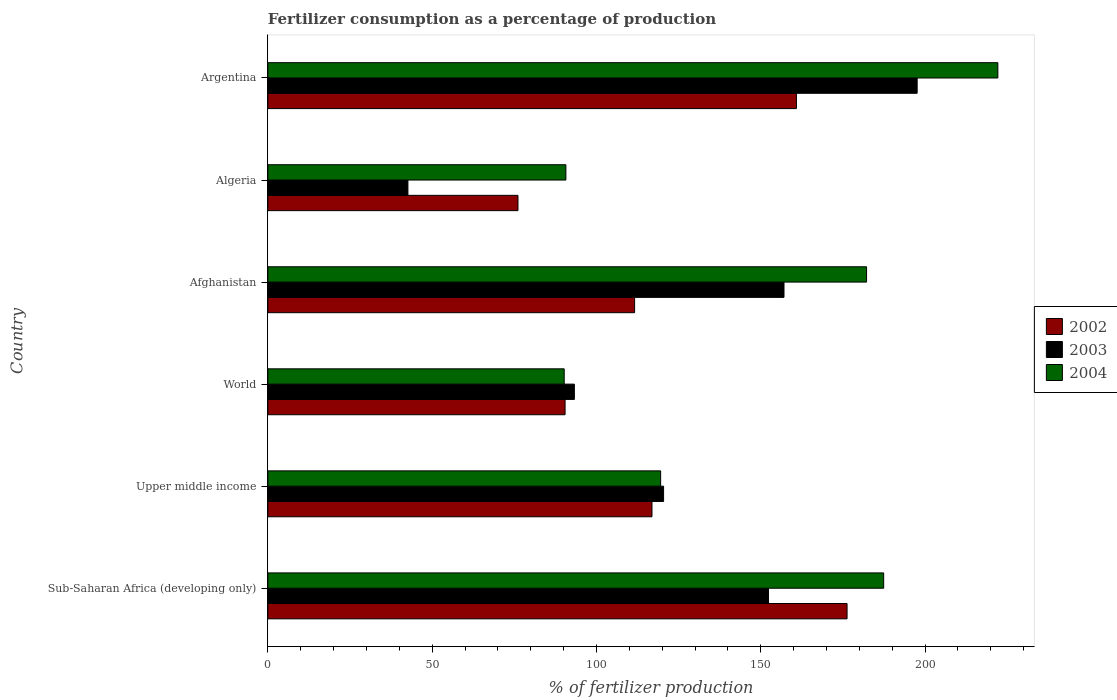How many different coloured bars are there?
Ensure brevity in your answer.  3. How many groups of bars are there?
Provide a succinct answer. 6. What is the label of the 6th group of bars from the top?
Give a very brief answer. Sub-Saharan Africa (developing only). In how many cases, is the number of bars for a given country not equal to the number of legend labels?
Your answer should be very brief. 0. What is the percentage of fertilizers consumed in 2004 in Argentina?
Ensure brevity in your answer.  222.14. Across all countries, what is the maximum percentage of fertilizers consumed in 2003?
Offer a terse response. 197.58. Across all countries, what is the minimum percentage of fertilizers consumed in 2004?
Keep it short and to the point. 90.18. In which country was the percentage of fertilizers consumed in 2003 maximum?
Offer a very short reply. Argentina. In which country was the percentage of fertilizers consumed in 2002 minimum?
Give a very brief answer. Algeria. What is the total percentage of fertilizers consumed in 2003 in the graph?
Give a very brief answer. 763.33. What is the difference between the percentage of fertilizers consumed in 2002 in Argentina and that in World?
Provide a short and direct response. 70.4. What is the difference between the percentage of fertilizers consumed in 2002 in Algeria and the percentage of fertilizers consumed in 2003 in Upper middle income?
Make the answer very short. -44.31. What is the average percentage of fertilizers consumed in 2002 per country?
Give a very brief answer. 122.03. What is the difference between the percentage of fertilizers consumed in 2003 and percentage of fertilizers consumed in 2002 in Upper middle income?
Provide a succinct answer. 3.53. What is the ratio of the percentage of fertilizers consumed in 2002 in Upper middle income to that in World?
Ensure brevity in your answer.  1.29. Is the difference between the percentage of fertilizers consumed in 2003 in Upper middle income and World greater than the difference between the percentage of fertilizers consumed in 2002 in Upper middle income and World?
Provide a short and direct response. Yes. What is the difference between the highest and the second highest percentage of fertilizers consumed in 2003?
Keep it short and to the point. 40.52. What is the difference between the highest and the lowest percentage of fertilizers consumed in 2004?
Your response must be concise. 131.96. Is the sum of the percentage of fertilizers consumed in 2002 in Afghanistan and World greater than the maximum percentage of fertilizers consumed in 2003 across all countries?
Keep it short and to the point. Yes. What does the 1st bar from the bottom in World represents?
Offer a very short reply. 2002. How many bars are there?
Offer a very short reply. 18. Are all the bars in the graph horizontal?
Give a very brief answer. Yes. Are the values on the major ticks of X-axis written in scientific E-notation?
Your response must be concise. No. Does the graph contain any zero values?
Your answer should be very brief. No. Does the graph contain grids?
Provide a short and direct response. No. How are the legend labels stacked?
Provide a succinct answer. Vertical. What is the title of the graph?
Your response must be concise. Fertilizer consumption as a percentage of production. What is the label or title of the X-axis?
Your response must be concise. % of fertilizer production. What is the label or title of the Y-axis?
Provide a short and direct response. Country. What is the % of fertilizer production in 2002 in Sub-Saharan Africa (developing only)?
Offer a terse response. 176.25. What is the % of fertilizer production of 2003 in Sub-Saharan Africa (developing only)?
Your answer should be compact. 152.35. What is the % of fertilizer production in 2004 in Sub-Saharan Africa (developing only)?
Make the answer very short. 187.4. What is the % of fertilizer production in 2002 in Upper middle income?
Provide a succinct answer. 116.9. What is the % of fertilizer production in 2003 in Upper middle income?
Offer a very short reply. 120.42. What is the % of fertilizer production in 2004 in Upper middle income?
Offer a terse response. 119.53. What is the % of fertilizer production in 2002 in World?
Offer a very short reply. 90.45. What is the % of fertilizer production in 2003 in World?
Provide a short and direct response. 93.27. What is the % of fertilizer production of 2004 in World?
Keep it short and to the point. 90.18. What is the % of fertilizer production of 2002 in Afghanistan?
Your response must be concise. 111.6. What is the % of fertilizer production in 2003 in Afghanistan?
Your response must be concise. 157.07. What is the % of fertilizer production of 2004 in Afghanistan?
Offer a terse response. 182.19. What is the % of fertilizer production of 2002 in Algeria?
Offer a very short reply. 76.11. What is the % of fertilizer production of 2003 in Algeria?
Your answer should be very brief. 42.63. What is the % of fertilizer production in 2004 in Algeria?
Make the answer very short. 90.69. What is the % of fertilizer production in 2002 in Argentina?
Offer a very short reply. 160.85. What is the % of fertilizer production of 2003 in Argentina?
Ensure brevity in your answer.  197.58. What is the % of fertilizer production of 2004 in Argentina?
Provide a short and direct response. 222.14. Across all countries, what is the maximum % of fertilizer production in 2002?
Your answer should be compact. 176.25. Across all countries, what is the maximum % of fertilizer production of 2003?
Keep it short and to the point. 197.58. Across all countries, what is the maximum % of fertilizer production of 2004?
Provide a succinct answer. 222.14. Across all countries, what is the minimum % of fertilizer production of 2002?
Keep it short and to the point. 76.11. Across all countries, what is the minimum % of fertilizer production of 2003?
Your answer should be very brief. 42.63. Across all countries, what is the minimum % of fertilizer production in 2004?
Offer a terse response. 90.18. What is the total % of fertilizer production in 2002 in the graph?
Your answer should be very brief. 732.17. What is the total % of fertilizer production of 2003 in the graph?
Offer a terse response. 763.33. What is the total % of fertilizer production in 2004 in the graph?
Provide a short and direct response. 892.13. What is the difference between the % of fertilizer production of 2002 in Sub-Saharan Africa (developing only) and that in Upper middle income?
Your answer should be very brief. 59.36. What is the difference between the % of fertilizer production of 2003 in Sub-Saharan Africa (developing only) and that in Upper middle income?
Your response must be concise. 31.93. What is the difference between the % of fertilizer production in 2004 in Sub-Saharan Africa (developing only) and that in Upper middle income?
Offer a very short reply. 67.87. What is the difference between the % of fertilizer production of 2002 in Sub-Saharan Africa (developing only) and that in World?
Your answer should be compact. 85.8. What is the difference between the % of fertilizer production of 2003 in Sub-Saharan Africa (developing only) and that in World?
Ensure brevity in your answer.  59.08. What is the difference between the % of fertilizer production of 2004 in Sub-Saharan Africa (developing only) and that in World?
Your answer should be compact. 97.21. What is the difference between the % of fertilizer production in 2002 in Sub-Saharan Africa (developing only) and that in Afghanistan?
Your response must be concise. 64.65. What is the difference between the % of fertilizer production of 2003 in Sub-Saharan Africa (developing only) and that in Afghanistan?
Make the answer very short. -4.71. What is the difference between the % of fertilizer production of 2004 in Sub-Saharan Africa (developing only) and that in Afghanistan?
Your response must be concise. 5.21. What is the difference between the % of fertilizer production in 2002 in Sub-Saharan Africa (developing only) and that in Algeria?
Your answer should be very brief. 100.14. What is the difference between the % of fertilizer production of 2003 in Sub-Saharan Africa (developing only) and that in Algeria?
Keep it short and to the point. 109.73. What is the difference between the % of fertilizer production in 2004 in Sub-Saharan Africa (developing only) and that in Algeria?
Your answer should be compact. 96.7. What is the difference between the % of fertilizer production in 2002 in Sub-Saharan Africa (developing only) and that in Argentina?
Your answer should be compact. 15.4. What is the difference between the % of fertilizer production in 2003 in Sub-Saharan Africa (developing only) and that in Argentina?
Provide a succinct answer. -45.23. What is the difference between the % of fertilizer production in 2004 in Sub-Saharan Africa (developing only) and that in Argentina?
Your response must be concise. -34.75. What is the difference between the % of fertilizer production in 2002 in Upper middle income and that in World?
Your response must be concise. 26.45. What is the difference between the % of fertilizer production of 2003 in Upper middle income and that in World?
Your answer should be compact. 27.15. What is the difference between the % of fertilizer production of 2004 in Upper middle income and that in World?
Offer a terse response. 29.35. What is the difference between the % of fertilizer production in 2002 in Upper middle income and that in Afghanistan?
Offer a very short reply. 5.29. What is the difference between the % of fertilizer production of 2003 in Upper middle income and that in Afghanistan?
Give a very brief answer. -36.64. What is the difference between the % of fertilizer production of 2004 in Upper middle income and that in Afghanistan?
Ensure brevity in your answer.  -62.66. What is the difference between the % of fertilizer production in 2002 in Upper middle income and that in Algeria?
Ensure brevity in your answer.  40.78. What is the difference between the % of fertilizer production in 2003 in Upper middle income and that in Algeria?
Your answer should be very brief. 77.8. What is the difference between the % of fertilizer production of 2004 in Upper middle income and that in Algeria?
Your answer should be compact. 28.84. What is the difference between the % of fertilizer production in 2002 in Upper middle income and that in Argentina?
Provide a succinct answer. -43.96. What is the difference between the % of fertilizer production in 2003 in Upper middle income and that in Argentina?
Give a very brief answer. -77.16. What is the difference between the % of fertilizer production in 2004 in Upper middle income and that in Argentina?
Your response must be concise. -102.62. What is the difference between the % of fertilizer production of 2002 in World and that in Afghanistan?
Ensure brevity in your answer.  -21.15. What is the difference between the % of fertilizer production in 2003 in World and that in Afghanistan?
Offer a terse response. -63.79. What is the difference between the % of fertilizer production of 2004 in World and that in Afghanistan?
Your answer should be compact. -92.01. What is the difference between the % of fertilizer production of 2002 in World and that in Algeria?
Ensure brevity in your answer.  14.34. What is the difference between the % of fertilizer production in 2003 in World and that in Algeria?
Provide a short and direct response. 50.65. What is the difference between the % of fertilizer production of 2004 in World and that in Algeria?
Offer a terse response. -0.51. What is the difference between the % of fertilizer production in 2002 in World and that in Argentina?
Your answer should be compact. -70.4. What is the difference between the % of fertilizer production in 2003 in World and that in Argentina?
Your answer should be compact. -104.31. What is the difference between the % of fertilizer production of 2004 in World and that in Argentina?
Offer a very short reply. -131.96. What is the difference between the % of fertilizer production of 2002 in Afghanistan and that in Algeria?
Make the answer very short. 35.49. What is the difference between the % of fertilizer production in 2003 in Afghanistan and that in Algeria?
Provide a succinct answer. 114.44. What is the difference between the % of fertilizer production of 2004 in Afghanistan and that in Algeria?
Offer a very short reply. 91.5. What is the difference between the % of fertilizer production in 2002 in Afghanistan and that in Argentina?
Keep it short and to the point. -49.25. What is the difference between the % of fertilizer production in 2003 in Afghanistan and that in Argentina?
Offer a very short reply. -40.52. What is the difference between the % of fertilizer production in 2004 in Afghanistan and that in Argentina?
Keep it short and to the point. -39.96. What is the difference between the % of fertilizer production of 2002 in Algeria and that in Argentina?
Provide a short and direct response. -84.74. What is the difference between the % of fertilizer production in 2003 in Algeria and that in Argentina?
Offer a terse response. -154.96. What is the difference between the % of fertilizer production in 2004 in Algeria and that in Argentina?
Your answer should be very brief. -131.45. What is the difference between the % of fertilizer production in 2002 in Sub-Saharan Africa (developing only) and the % of fertilizer production in 2003 in Upper middle income?
Give a very brief answer. 55.83. What is the difference between the % of fertilizer production of 2002 in Sub-Saharan Africa (developing only) and the % of fertilizer production of 2004 in Upper middle income?
Your answer should be compact. 56.73. What is the difference between the % of fertilizer production in 2003 in Sub-Saharan Africa (developing only) and the % of fertilizer production in 2004 in Upper middle income?
Give a very brief answer. 32.82. What is the difference between the % of fertilizer production in 2002 in Sub-Saharan Africa (developing only) and the % of fertilizer production in 2003 in World?
Provide a short and direct response. 82.98. What is the difference between the % of fertilizer production in 2002 in Sub-Saharan Africa (developing only) and the % of fertilizer production in 2004 in World?
Your answer should be very brief. 86.07. What is the difference between the % of fertilizer production of 2003 in Sub-Saharan Africa (developing only) and the % of fertilizer production of 2004 in World?
Make the answer very short. 62.17. What is the difference between the % of fertilizer production of 2002 in Sub-Saharan Africa (developing only) and the % of fertilizer production of 2003 in Afghanistan?
Offer a very short reply. 19.19. What is the difference between the % of fertilizer production in 2002 in Sub-Saharan Africa (developing only) and the % of fertilizer production in 2004 in Afghanistan?
Offer a terse response. -5.93. What is the difference between the % of fertilizer production of 2003 in Sub-Saharan Africa (developing only) and the % of fertilizer production of 2004 in Afghanistan?
Give a very brief answer. -29.84. What is the difference between the % of fertilizer production in 2002 in Sub-Saharan Africa (developing only) and the % of fertilizer production in 2003 in Algeria?
Your answer should be very brief. 133.63. What is the difference between the % of fertilizer production in 2002 in Sub-Saharan Africa (developing only) and the % of fertilizer production in 2004 in Algeria?
Your answer should be compact. 85.56. What is the difference between the % of fertilizer production in 2003 in Sub-Saharan Africa (developing only) and the % of fertilizer production in 2004 in Algeria?
Give a very brief answer. 61.66. What is the difference between the % of fertilizer production in 2002 in Sub-Saharan Africa (developing only) and the % of fertilizer production in 2003 in Argentina?
Provide a succinct answer. -21.33. What is the difference between the % of fertilizer production of 2002 in Sub-Saharan Africa (developing only) and the % of fertilizer production of 2004 in Argentina?
Provide a succinct answer. -45.89. What is the difference between the % of fertilizer production in 2003 in Sub-Saharan Africa (developing only) and the % of fertilizer production in 2004 in Argentina?
Offer a terse response. -69.79. What is the difference between the % of fertilizer production in 2002 in Upper middle income and the % of fertilizer production in 2003 in World?
Your response must be concise. 23.62. What is the difference between the % of fertilizer production in 2002 in Upper middle income and the % of fertilizer production in 2004 in World?
Offer a terse response. 26.71. What is the difference between the % of fertilizer production in 2003 in Upper middle income and the % of fertilizer production in 2004 in World?
Your response must be concise. 30.24. What is the difference between the % of fertilizer production of 2002 in Upper middle income and the % of fertilizer production of 2003 in Afghanistan?
Your answer should be compact. -40.17. What is the difference between the % of fertilizer production of 2002 in Upper middle income and the % of fertilizer production of 2004 in Afghanistan?
Provide a short and direct response. -65.29. What is the difference between the % of fertilizer production of 2003 in Upper middle income and the % of fertilizer production of 2004 in Afghanistan?
Your response must be concise. -61.76. What is the difference between the % of fertilizer production of 2002 in Upper middle income and the % of fertilizer production of 2003 in Algeria?
Offer a terse response. 74.27. What is the difference between the % of fertilizer production of 2002 in Upper middle income and the % of fertilizer production of 2004 in Algeria?
Keep it short and to the point. 26.2. What is the difference between the % of fertilizer production in 2003 in Upper middle income and the % of fertilizer production in 2004 in Algeria?
Offer a terse response. 29.73. What is the difference between the % of fertilizer production in 2002 in Upper middle income and the % of fertilizer production in 2003 in Argentina?
Provide a succinct answer. -80.69. What is the difference between the % of fertilizer production in 2002 in Upper middle income and the % of fertilizer production in 2004 in Argentina?
Your answer should be very brief. -105.25. What is the difference between the % of fertilizer production in 2003 in Upper middle income and the % of fertilizer production in 2004 in Argentina?
Provide a short and direct response. -101.72. What is the difference between the % of fertilizer production of 2002 in World and the % of fertilizer production of 2003 in Afghanistan?
Your response must be concise. -66.62. What is the difference between the % of fertilizer production of 2002 in World and the % of fertilizer production of 2004 in Afghanistan?
Keep it short and to the point. -91.74. What is the difference between the % of fertilizer production in 2003 in World and the % of fertilizer production in 2004 in Afghanistan?
Offer a very short reply. -88.91. What is the difference between the % of fertilizer production of 2002 in World and the % of fertilizer production of 2003 in Algeria?
Provide a short and direct response. 47.82. What is the difference between the % of fertilizer production in 2002 in World and the % of fertilizer production in 2004 in Algeria?
Your answer should be very brief. -0.24. What is the difference between the % of fertilizer production in 2003 in World and the % of fertilizer production in 2004 in Algeria?
Make the answer very short. 2.58. What is the difference between the % of fertilizer production in 2002 in World and the % of fertilizer production in 2003 in Argentina?
Your response must be concise. -107.14. What is the difference between the % of fertilizer production of 2002 in World and the % of fertilizer production of 2004 in Argentina?
Your answer should be compact. -131.7. What is the difference between the % of fertilizer production of 2003 in World and the % of fertilizer production of 2004 in Argentina?
Your answer should be very brief. -128.87. What is the difference between the % of fertilizer production in 2002 in Afghanistan and the % of fertilizer production in 2003 in Algeria?
Offer a terse response. 68.98. What is the difference between the % of fertilizer production of 2002 in Afghanistan and the % of fertilizer production of 2004 in Algeria?
Offer a terse response. 20.91. What is the difference between the % of fertilizer production in 2003 in Afghanistan and the % of fertilizer production in 2004 in Algeria?
Provide a succinct answer. 66.37. What is the difference between the % of fertilizer production of 2002 in Afghanistan and the % of fertilizer production of 2003 in Argentina?
Ensure brevity in your answer.  -85.98. What is the difference between the % of fertilizer production of 2002 in Afghanistan and the % of fertilizer production of 2004 in Argentina?
Your response must be concise. -110.54. What is the difference between the % of fertilizer production in 2003 in Afghanistan and the % of fertilizer production in 2004 in Argentina?
Make the answer very short. -65.08. What is the difference between the % of fertilizer production in 2002 in Algeria and the % of fertilizer production in 2003 in Argentina?
Your answer should be compact. -121.47. What is the difference between the % of fertilizer production of 2002 in Algeria and the % of fertilizer production of 2004 in Argentina?
Provide a succinct answer. -146.03. What is the difference between the % of fertilizer production of 2003 in Algeria and the % of fertilizer production of 2004 in Argentina?
Your response must be concise. -179.52. What is the average % of fertilizer production of 2002 per country?
Ensure brevity in your answer.  122.03. What is the average % of fertilizer production of 2003 per country?
Provide a short and direct response. 127.22. What is the average % of fertilizer production in 2004 per country?
Ensure brevity in your answer.  148.69. What is the difference between the % of fertilizer production of 2002 and % of fertilizer production of 2003 in Sub-Saharan Africa (developing only)?
Make the answer very short. 23.9. What is the difference between the % of fertilizer production in 2002 and % of fertilizer production in 2004 in Sub-Saharan Africa (developing only)?
Give a very brief answer. -11.14. What is the difference between the % of fertilizer production in 2003 and % of fertilizer production in 2004 in Sub-Saharan Africa (developing only)?
Your response must be concise. -35.04. What is the difference between the % of fertilizer production in 2002 and % of fertilizer production in 2003 in Upper middle income?
Your answer should be compact. -3.53. What is the difference between the % of fertilizer production in 2002 and % of fertilizer production in 2004 in Upper middle income?
Keep it short and to the point. -2.63. What is the difference between the % of fertilizer production of 2003 and % of fertilizer production of 2004 in Upper middle income?
Provide a short and direct response. 0.89. What is the difference between the % of fertilizer production in 2002 and % of fertilizer production in 2003 in World?
Ensure brevity in your answer.  -2.83. What is the difference between the % of fertilizer production in 2002 and % of fertilizer production in 2004 in World?
Keep it short and to the point. 0.27. What is the difference between the % of fertilizer production in 2003 and % of fertilizer production in 2004 in World?
Your answer should be compact. 3.09. What is the difference between the % of fertilizer production of 2002 and % of fertilizer production of 2003 in Afghanistan?
Keep it short and to the point. -45.46. What is the difference between the % of fertilizer production in 2002 and % of fertilizer production in 2004 in Afghanistan?
Provide a short and direct response. -70.58. What is the difference between the % of fertilizer production of 2003 and % of fertilizer production of 2004 in Afghanistan?
Give a very brief answer. -25.12. What is the difference between the % of fertilizer production of 2002 and % of fertilizer production of 2003 in Algeria?
Your response must be concise. 33.49. What is the difference between the % of fertilizer production of 2002 and % of fertilizer production of 2004 in Algeria?
Provide a succinct answer. -14.58. What is the difference between the % of fertilizer production in 2003 and % of fertilizer production in 2004 in Algeria?
Your answer should be very brief. -48.06. What is the difference between the % of fertilizer production in 2002 and % of fertilizer production in 2003 in Argentina?
Your answer should be compact. -36.73. What is the difference between the % of fertilizer production in 2002 and % of fertilizer production in 2004 in Argentina?
Provide a succinct answer. -61.29. What is the difference between the % of fertilizer production in 2003 and % of fertilizer production in 2004 in Argentina?
Your answer should be compact. -24.56. What is the ratio of the % of fertilizer production of 2002 in Sub-Saharan Africa (developing only) to that in Upper middle income?
Ensure brevity in your answer.  1.51. What is the ratio of the % of fertilizer production in 2003 in Sub-Saharan Africa (developing only) to that in Upper middle income?
Provide a short and direct response. 1.27. What is the ratio of the % of fertilizer production of 2004 in Sub-Saharan Africa (developing only) to that in Upper middle income?
Provide a short and direct response. 1.57. What is the ratio of the % of fertilizer production in 2002 in Sub-Saharan Africa (developing only) to that in World?
Provide a succinct answer. 1.95. What is the ratio of the % of fertilizer production of 2003 in Sub-Saharan Africa (developing only) to that in World?
Ensure brevity in your answer.  1.63. What is the ratio of the % of fertilizer production of 2004 in Sub-Saharan Africa (developing only) to that in World?
Make the answer very short. 2.08. What is the ratio of the % of fertilizer production of 2002 in Sub-Saharan Africa (developing only) to that in Afghanistan?
Your answer should be very brief. 1.58. What is the ratio of the % of fertilizer production in 2004 in Sub-Saharan Africa (developing only) to that in Afghanistan?
Provide a succinct answer. 1.03. What is the ratio of the % of fertilizer production of 2002 in Sub-Saharan Africa (developing only) to that in Algeria?
Make the answer very short. 2.32. What is the ratio of the % of fertilizer production in 2003 in Sub-Saharan Africa (developing only) to that in Algeria?
Give a very brief answer. 3.57. What is the ratio of the % of fertilizer production in 2004 in Sub-Saharan Africa (developing only) to that in Algeria?
Ensure brevity in your answer.  2.07. What is the ratio of the % of fertilizer production in 2002 in Sub-Saharan Africa (developing only) to that in Argentina?
Your answer should be very brief. 1.1. What is the ratio of the % of fertilizer production of 2003 in Sub-Saharan Africa (developing only) to that in Argentina?
Give a very brief answer. 0.77. What is the ratio of the % of fertilizer production of 2004 in Sub-Saharan Africa (developing only) to that in Argentina?
Offer a very short reply. 0.84. What is the ratio of the % of fertilizer production in 2002 in Upper middle income to that in World?
Your answer should be compact. 1.29. What is the ratio of the % of fertilizer production of 2003 in Upper middle income to that in World?
Make the answer very short. 1.29. What is the ratio of the % of fertilizer production of 2004 in Upper middle income to that in World?
Give a very brief answer. 1.33. What is the ratio of the % of fertilizer production of 2002 in Upper middle income to that in Afghanistan?
Your response must be concise. 1.05. What is the ratio of the % of fertilizer production in 2003 in Upper middle income to that in Afghanistan?
Your answer should be very brief. 0.77. What is the ratio of the % of fertilizer production in 2004 in Upper middle income to that in Afghanistan?
Your answer should be compact. 0.66. What is the ratio of the % of fertilizer production in 2002 in Upper middle income to that in Algeria?
Your answer should be very brief. 1.54. What is the ratio of the % of fertilizer production of 2003 in Upper middle income to that in Algeria?
Provide a short and direct response. 2.83. What is the ratio of the % of fertilizer production in 2004 in Upper middle income to that in Algeria?
Provide a short and direct response. 1.32. What is the ratio of the % of fertilizer production in 2002 in Upper middle income to that in Argentina?
Provide a succinct answer. 0.73. What is the ratio of the % of fertilizer production in 2003 in Upper middle income to that in Argentina?
Your answer should be very brief. 0.61. What is the ratio of the % of fertilizer production of 2004 in Upper middle income to that in Argentina?
Keep it short and to the point. 0.54. What is the ratio of the % of fertilizer production in 2002 in World to that in Afghanistan?
Your response must be concise. 0.81. What is the ratio of the % of fertilizer production of 2003 in World to that in Afghanistan?
Ensure brevity in your answer.  0.59. What is the ratio of the % of fertilizer production of 2004 in World to that in Afghanistan?
Give a very brief answer. 0.49. What is the ratio of the % of fertilizer production in 2002 in World to that in Algeria?
Provide a short and direct response. 1.19. What is the ratio of the % of fertilizer production in 2003 in World to that in Algeria?
Give a very brief answer. 2.19. What is the ratio of the % of fertilizer production of 2004 in World to that in Algeria?
Give a very brief answer. 0.99. What is the ratio of the % of fertilizer production of 2002 in World to that in Argentina?
Provide a succinct answer. 0.56. What is the ratio of the % of fertilizer production in 2003 in World to that in Argentina?
Give a very brief answer. 0.47. What is the ratio of the % of fertilizer production of 2004 in World to that in Argentina?
Ensure brevity in your answer.  0.41. What is the ratio of the % of fertilizer production in 2002 in Afghanistan to that in Algeria?
Your response must be concise. 1.47. What is the ratio of the % of fertilizer production in 2003 in Afghanistan to that in Algeria?
Your answer should be very brief. 3.68. What is the ratio of the % of fertilizer production of 2004 in Afghanistan to that in Algeria?
Make the answer very short. 2.01. What is the ratio of the % of fertilizer production in 2002 in Afghanistan to that in Argentina?
Ensure brevity in your answer.  0.69. What is the ratio of the % of fertilizer production of 2003 in Afghanistan to that in Argentina?
Your answer should be compact. 0.79. What is the ratio of the % of fertilizer production in 2004 in Afghanistan to that in Argentina?
Offer a terse response. 0.82. What is the ratio of the % of fertilizer production of 2002 in Algeria to that in Argentina?
Keep it short and to the point. 0.47. What is the ratio of the % of fertilizer production in 2003 in Algeria to that in Argentina?
Ensure brevity in your answer.  0.22. What is the ratio of the % of fertilizer production in 2004 in Algeria to that in Argentina?
Provide a succinct answer. 0.41. What is the difference between the highest and the second highest % of fertilizer production in 2002?
Keep it short and to the point. 15.4. What is the difference between the highest and the second highest % of fertilizer production of 2003?
Keep it short and to the point. 40.52. What is the difference between the highest and the second highest % of fertilizer production of 2004?
Keep it short and to the point. 34.75. What is the difference between the highest and the lowest % of fertilizer production in 2002?
Make the answer very short. 100.14. What is the difference between the highest and the lowest % of fertilizer production of 2003?
Provide a succinct answer. 154.96. What is the difference between the highest and the lowest % of fertilizer production in 2004?
Provide a short and direct response. 131.96. 